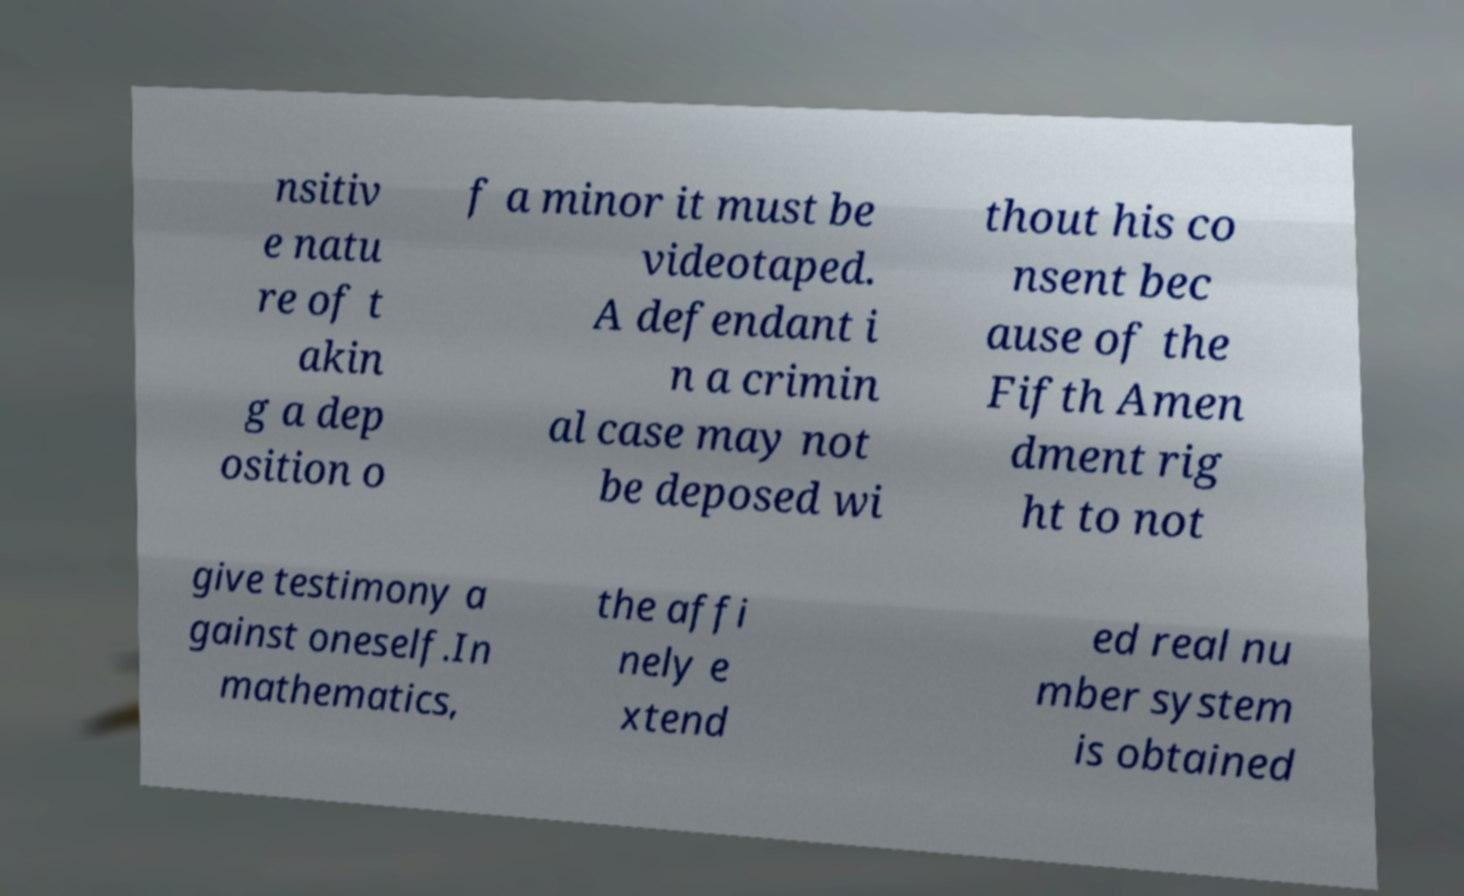There's text embedded in this image that I need extracted. Can you transcribe it verbatim? nsitiv e natu re of t akin g a dep osition o f a minor it must be videotaped. A defendant i n a crimin al case may not be deposed wi thout his co nsent bec ause of the Fifth Amen dment rig ht to not give testimony a gainst oneself.In mathematics, the affi nely e xtend ed real nu mber system is obtained 